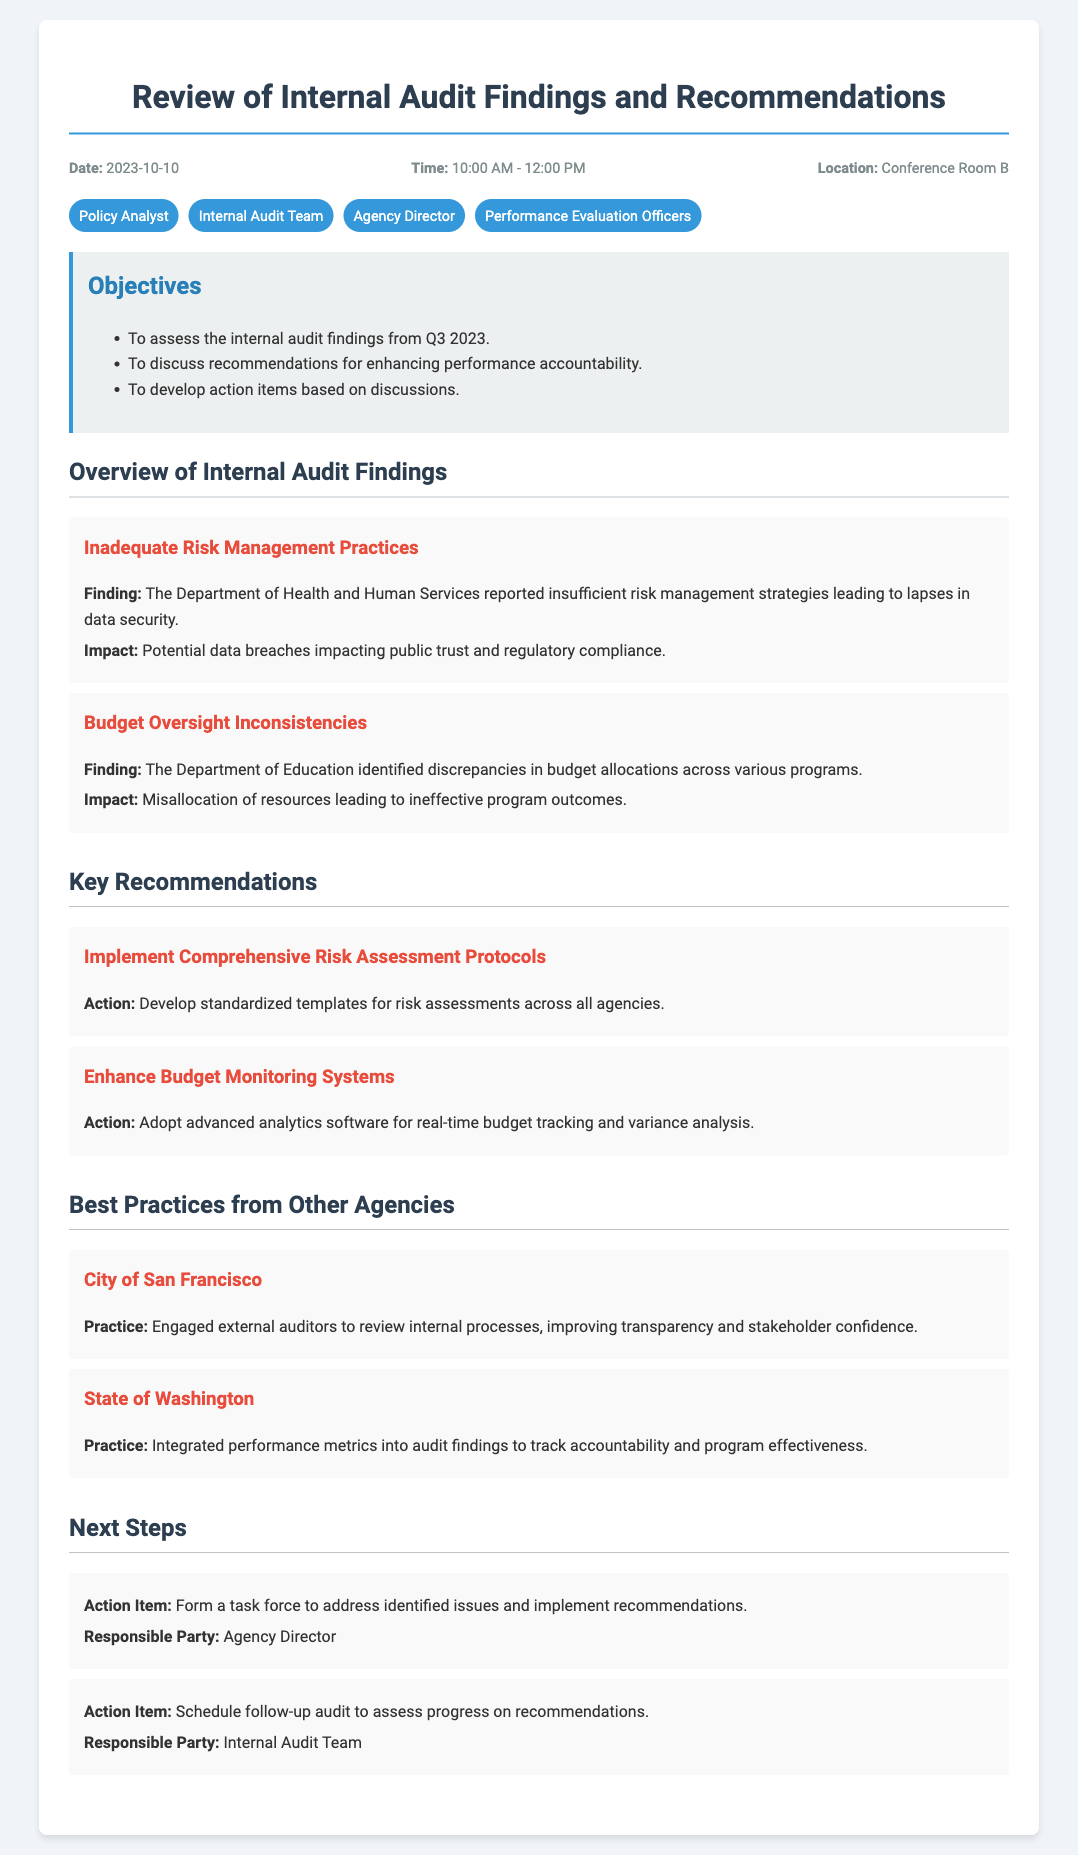What is the date of the meeting? The date of the meeting is specified in the "header-info" section of the document.
Answer: 2023-10-10 Who is responsible for scheduling the follow-up audit? The responsible party for scheduling the follow-up audit is mentioned in the "Next Steps" section of the document.
Answer: Internal Audit Team What is one key finding related to budget oversight? The document lists a specific finding about budget oversight under the "Overview of Internal Audit Findings" section.
Answer: Discrepancies in budget allocations across various programs What action is recommended to enhance budget monitoring? The recommendation for budget monitoring is detailed in the "Key Recommendations" section of the document.
Answer: Adopt advanced analytics software for real-time budget tracking and variance analysis Which agency reported inadequate risk management practices? The agency related to risk management practices is identified in the findings section of the document.
Answer: Department of Health and Human Services What is one best practice mentioned from another agency? A best practice from another agency can be found in the "Best Practices from Other Agencies" section of the document.
Answer: Engaged external auditors to review internal processes What is the time duration of the meeting? The time duration of the meeting is provided in the header information.
Answer: 10:00 AM - 12:00 PM What is the location of the meeting? The location of the meeting is given in the header info section of the agenda.
Answer: Conference Room B 